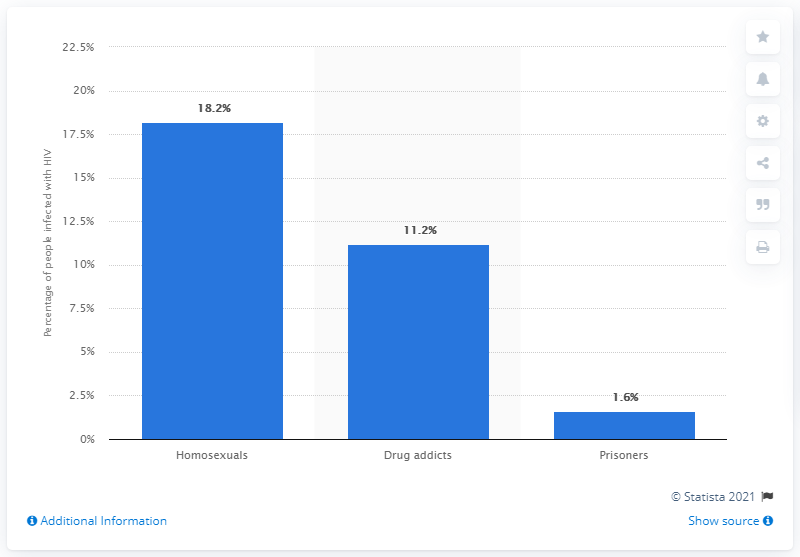List a handful of essential elements in this visual. In 2019, the HIV prevalence in Romania was 18.2%. In Romania, approximately 1.6% of prisoners were diagnosed with HIV during a study conducted in 2012. 